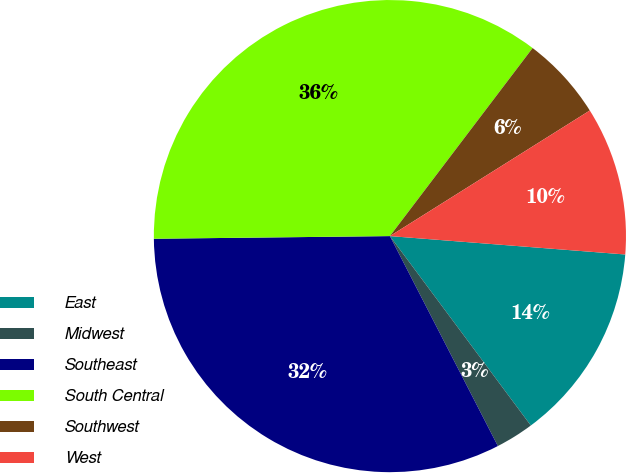Convert chart to OTSL. <chart><loc_0><loc_0><loc_500><loc_500><pie_chart><fcel>East<fcel>Midwest<fcel>Southeast<fcel>South Central<fcel>Southwest<fcel>West<nl><fcel>13.58%<fcel>2.62%<fcel>32.38%<fcel>35.51%<fcel>5.74%<fcel>10.17%<nl></chart> 